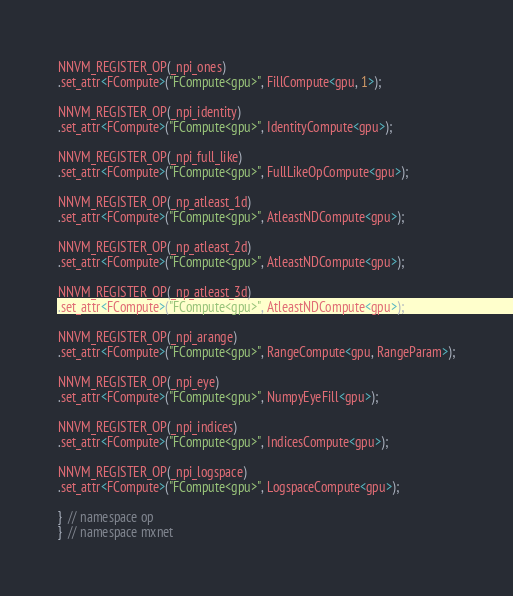<code> <loc_0><loc_0><loc_500><loc_500><_Cuda_>NNVM_REGISTER_OP(_npi_ones)
.set_attr<FCompute>("FCompute<gpu>", FillCompute<gpu, 1>);

NNVM_REGISTER_OP(_npi_identity)
.set_attr<FCompute>("FCompute<gpu>", IdentityCompute<gpu>);

NNVM_REGISTER_OP(_npi_full_like)
.set_attr<FCompute>("FCompute<gpu>", FullLikeOpCompute<gpu>);

NNVM_REGISTER_OP(_np_atleast_1d)
.set_attr<FCompute>("FCompute<gpu>", AtleastNDCompute<gpu>);

NNVM_REGISTER_OP(_np_atleast_2d)
.set_attr<FCompute>("FCompute<gpu>", AtleastNDCompute<gpu>);

NNVM_REGISTER_OP(_np_atleast_3d)
.set_attr<FCompute>("FCompute<gpu>", AtleastNDCompute<gpu>);

NNVM_REGISTER_OP(_npi_arange)
.set_attr<FCompute>("FCompute<gpu>", RangeCompute<gpu, RangeParam>);

NNVM_REGISTER_OP(_npi_eye)
.set_attr<FCompute>("FCompute<gpu>", NumpyEyeFill<gpu>);

NNVM_REGISTER_OP(_npi_indices)
.set_attr<FCompute>("FCompute<gpu>", IndicesCompute<gpu>);

NNVM_REGISTER_OP(_npi_logspace)
.set_attr<FCompute>("FCompute<gpu>", LogspaceCompute<gpu>);

}  // namespace op
}  // namespace mxnet
</code> 